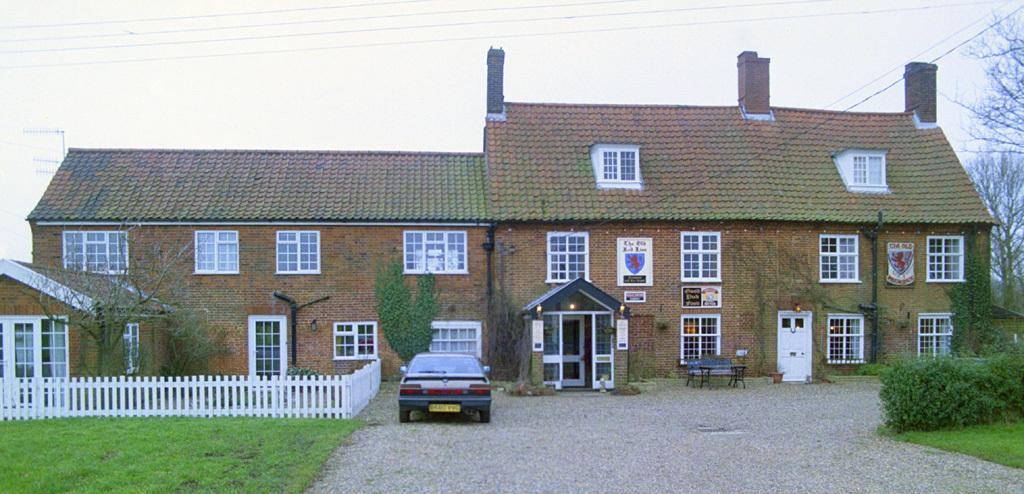What type of structure is present in the image? There is a house in the image. What features can be seen on the house? The house has windows and doors. What other objects are visible in the image? There are pipes, lights, fencing, a car, plants, grass, trees, a bench, and a table in the image. What part of the natural environment is visible in the image? The sky is visible in the image. What is the temper of the car in the image? The car in the image does not have a temper, as it is an inanimate object. What is the distance between the house and the trees in the image? The provided facts do not give information about the distance between the house and the trees, so it cannot be determined from the image. 